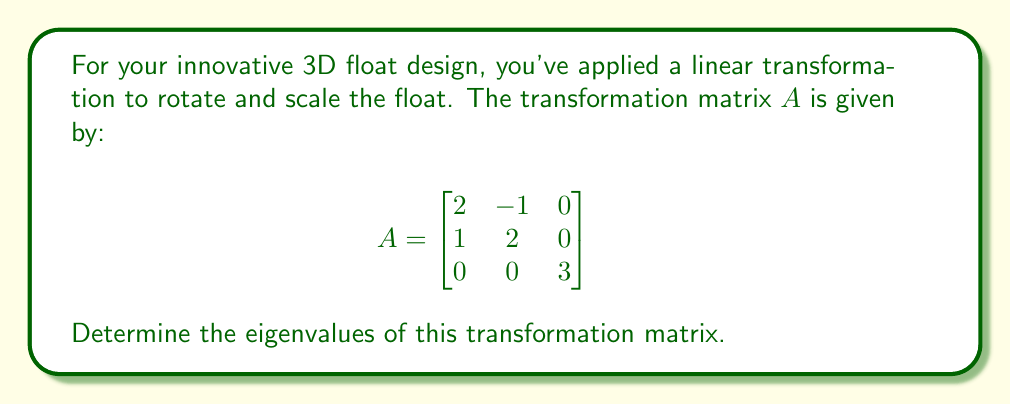Give your solution to this math problem. To find the eigenvalues of matrix $A$, we need to solve the characteristic equation:

1) First, we form the characteristic equation:
   $\det(A - \lambda I) = 0$, where $I$ is the 3x3 identity matrix.

2) Expand the determinant:
   $$\det\begin{bmatrix}
   2-\lambda & -1 & 0 \\
   1 & 2-\lambda & 0 \\
   0 & 0 & 3-\lambda
   \end{bmatrix} = 0$$

3) Calculate the determinant:
   $((2-\lambda)(2-\lambda) - (-1)(1))(3-\lambda) = 0$

4) Simplify:
   $((2-\lambda)^2 + 1)(3-\lambda) = 0$

5) Expand:
   $(\lambda^2 - 4\lambda + 5)(3-\lambda) = 0$

6) Factor the equation:
   $(\lambda - 2 + i)(\lambda - 2 - i)(3-\lambda) = 0$

7) Solve for $\lambda$:
   $\lambda = 2 + i$, or $\lambda = 2 - i$, or $\lambda = 3$

Therefore, the eigenvalues are $2+i$, $2-i$, and $3$.
Answer: $\lambda_1 = 2+i$, $\lambda_2 = 2-i$, $\lambda_3 = 3$ 